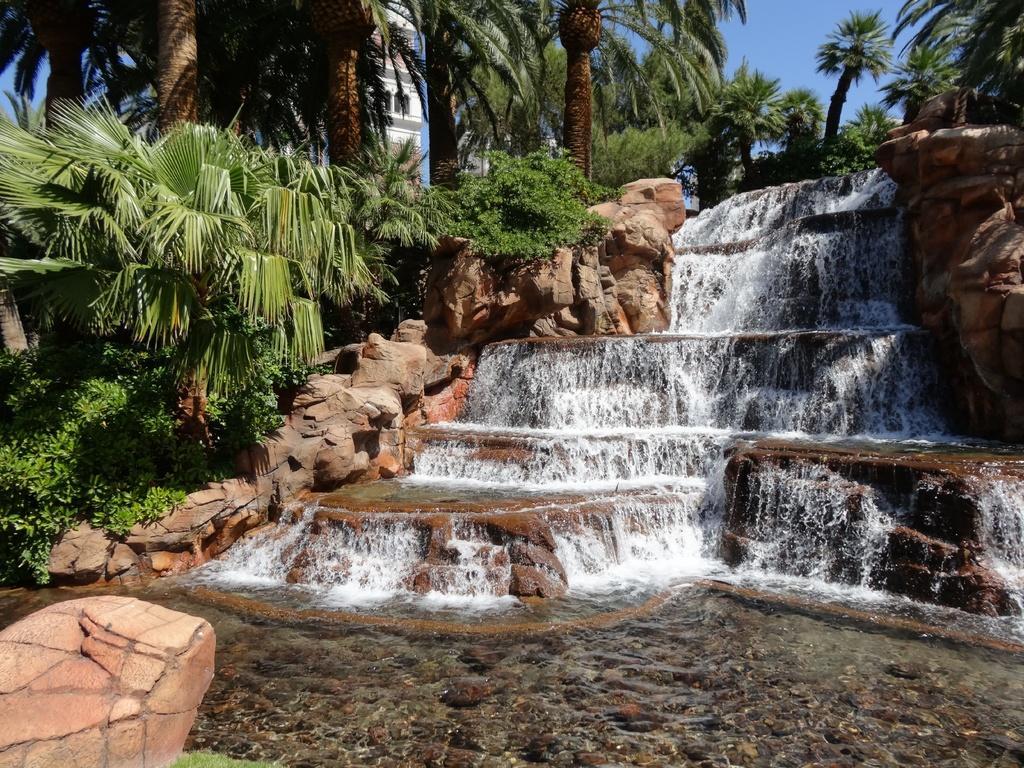In one or two sentences, can you explain what this image depicts? In this image, we can see trees, waterfalls, some plants and there is a building and rocks. At the top, there is sky and at the bottom, there is water. 